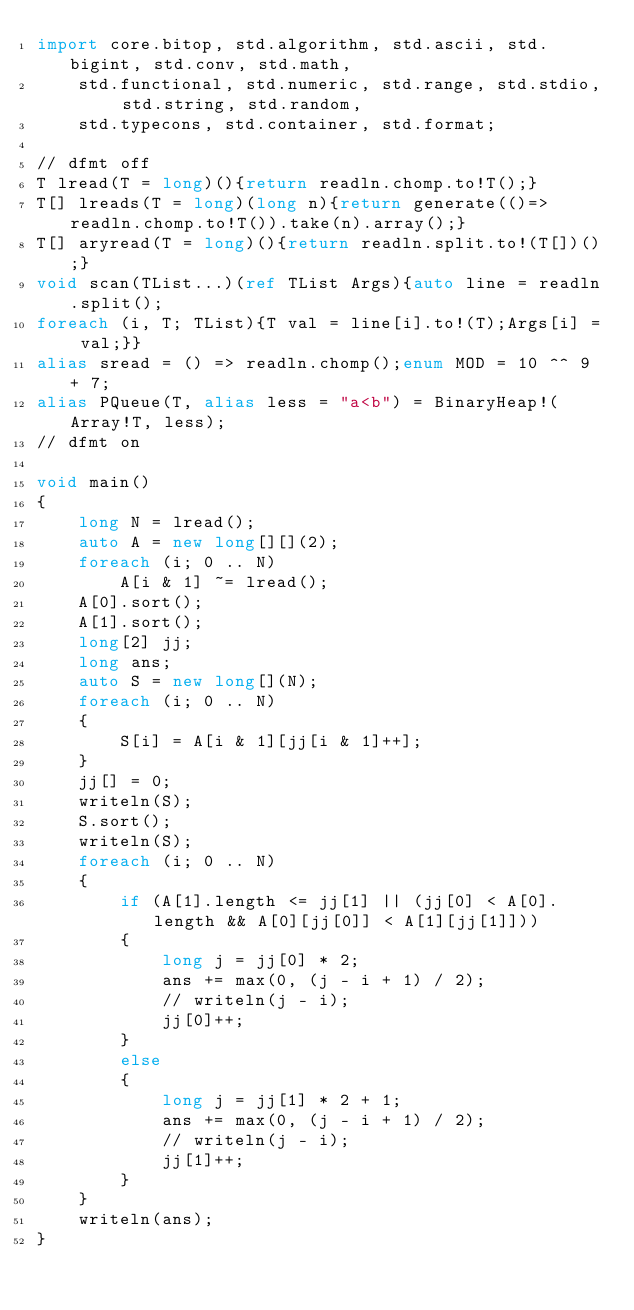<code> <loc_0><loc_0><loc_500><loc_500><_D_>import core.bitop, std.algorithm, std.ascii, std.bigint, std.conv, std.math,
    std.functional, std.numeric, std.range, std.stdio, std.string, std.random,
    std.typecons, std.container, std.format;

// dfmt off
T lread(T = long)(){return readln.chomp.to!T();}
T[] lreads(T = long)(long n){return generate(()=>readln.chomp.to!T()).take(n).array();}
T[] aryread(T = long)(){return readln.split.to!(T[])();}
void scan(TList...)(ref TList Args){auto line = readln.split();
foreach (i, T; TList){T val = line[i].to!(T);Args[i] = val;}}
alias sread = () => readln.chomp();enum MOD = 10 ^^ 9 + 7;
alias PQueue(T, alias less = "a<b") = BinaryHeap!(Array!T, less);
// dfmt on

void main()
{
    long N = lread();
    auto A = new long[][](2);
    foreach (i; 0 .. N)
        A[i & 1] ~= lread();
    A[0].sort();
    A[1].sort();
    long[2] jj;
    long ans;
    auto S = new long[](N);
    foreach (i; 0 .. N)
    {
        S[i] = A[i & 1][jj[i & 1]++];
    }
    jj[] = 0;
    writeln(S);
    S.sort();
    writeln(S);
    foreach (i; 0 .. N)
    {
        if (A[1].length <= jj[1] || (jj[0] < A[0].length && A[0][jj[0]] < A[1][jj[1]]))
        {
            long j = jj[0] * 2;
            ans += max(0, (j - i + 1) / 2);
            // writeln(j - i);
            jj[0]++;
        }
        else
        {
            long j = jj[1] * 2 + 1;
            ans += max(0, (j - i + 1) / 2);
            // writeln(j - i);
            jj[1]++;
        }
    }
    writeln(ans);
}
</code> 